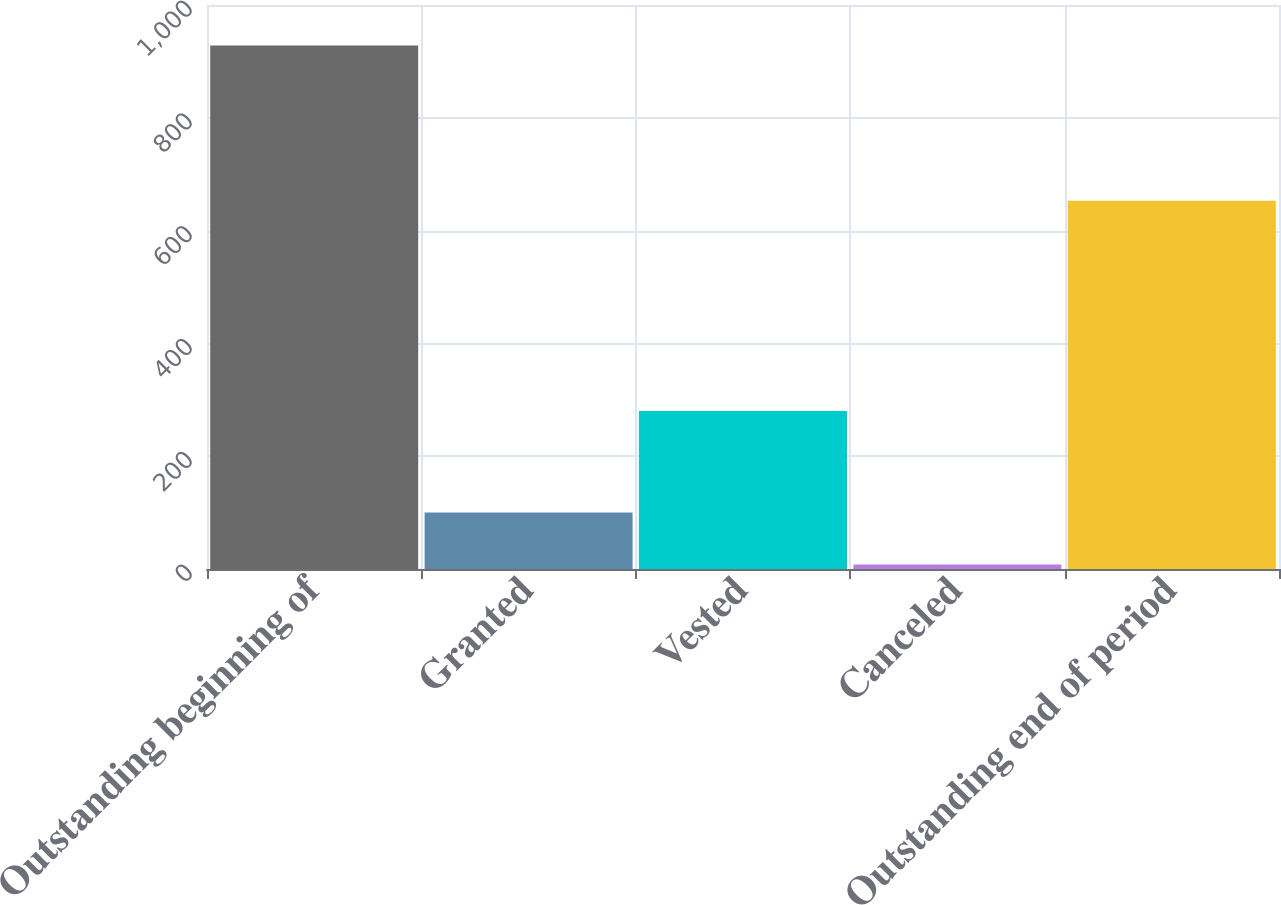<chart> <loc_0><loc_0><loc_500><loc_500><bar_chart><fcel>Outstanding beginning of<fcel>Granted<fcel>Vested<fcel>Canceled<fcel>Outstanding end of period<nl><fcel>928<fcel>100<fcel>280<fcel>8<fcel>653<nl></chart> 